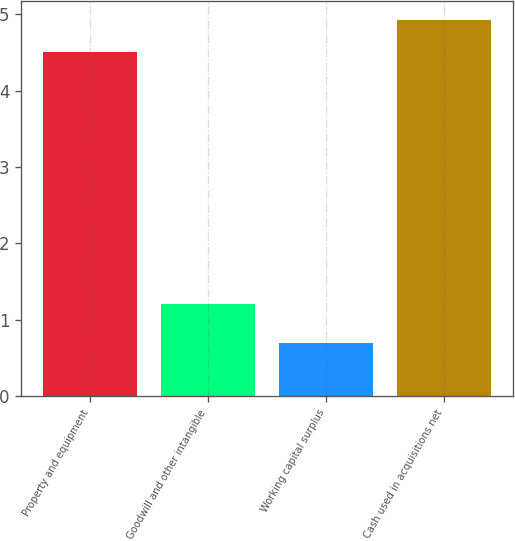Convert chart to OTSL. <chart><loc_0><loc_0><loc_500><loc_500><bar_chart><fcel>Property and equipment<fcel>Goodwill and other intangible<fcel>Working capital surplus<fcel>Cash used in acquisitions net<nl><fcel>4.5<fcel>1.2<fcel>0.7<fcel>4.92<nl></chart> 